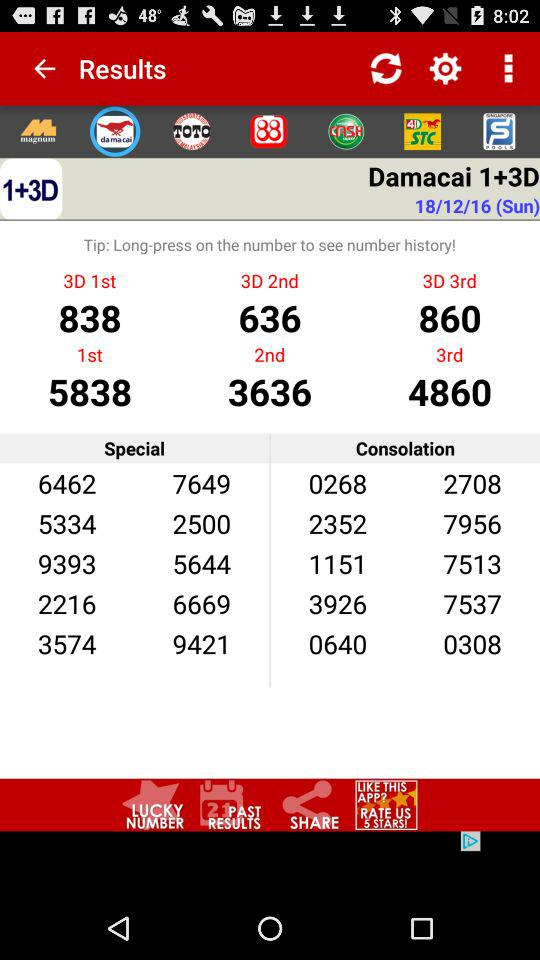What’s the number for the 3rd prize for 3D?
When the provided information is insufficient, respond with <no answer>. <no answer> 